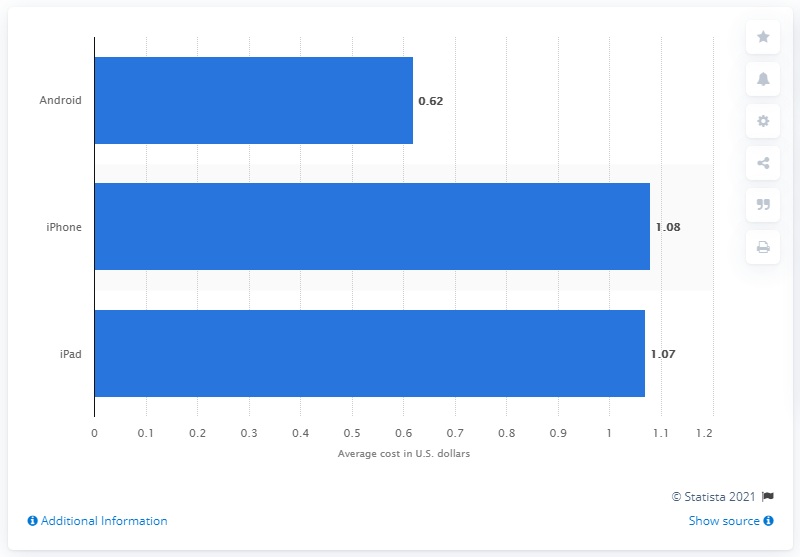Point out several critical features in this image. The average CPI (cost per install) for Android apps during the measured period was 0.62.. 